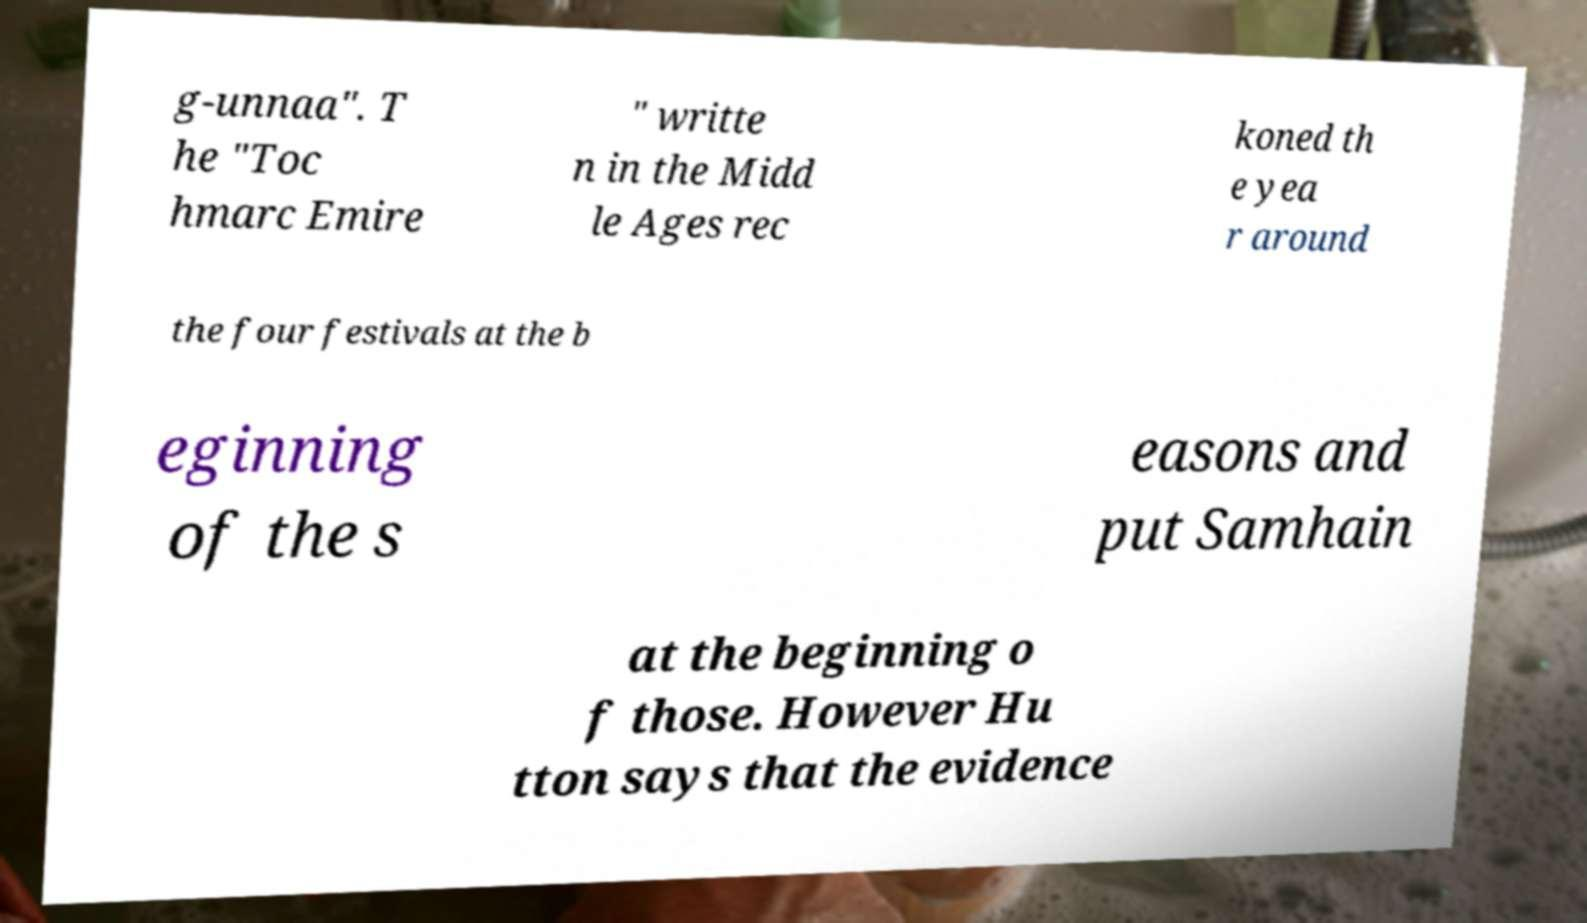Could you extract and type out the text from this image? g-unnaa". T he "Toc hmarc Emire " writte n in the Midd le Ages rec koned th e yea r around the four festivals at the b eginning of the s easons and put Samhain at the beginning o f those. However Hu tton says that the evidence 